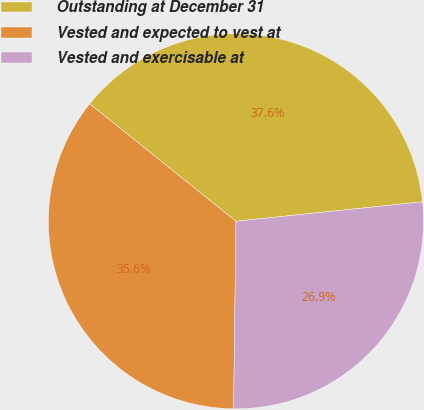Convert chart to OTSL. <chart><loc_0><loc_0><loc_500><loc_500><pie_chart><fcel>Outstanding at December 31<fcel>Vested and expected to vest at<fcel>Vested and exercisable at<nl><fcel>37.58%<fcel>35.57%<fcel>26.85%<nl></chart> 